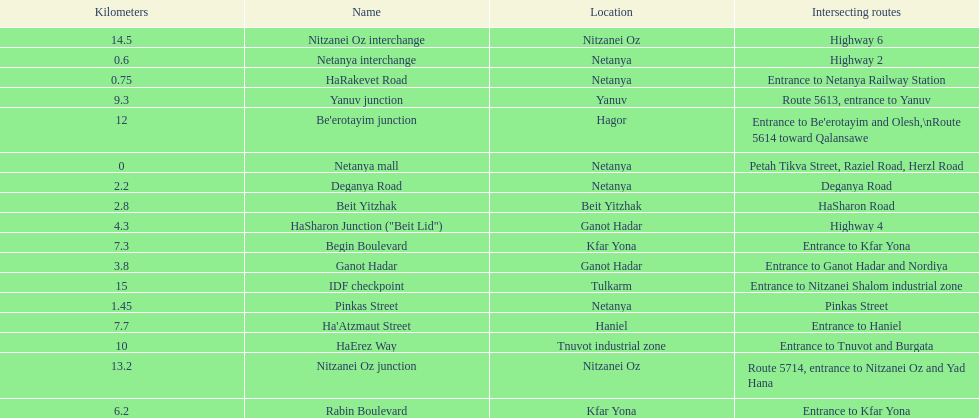Which portion has the same intersecting route as rabin boulevard? Begin Boulevard. 